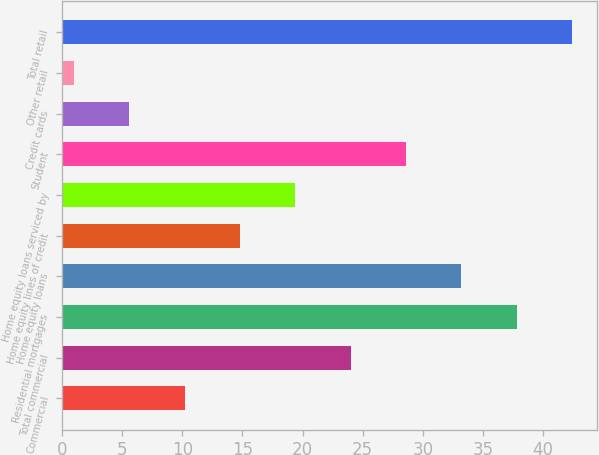Convert chart to OTSL. <chart><loc_0><loc_0><loc_500><loc_500><bar_chart><fcel>Commercial<fcel>Total commercial<fcel>Residential mortgages<fcel>Home equity loans<fcel>Home equity lines of credit<fcel>Home equity loans serviced by<fcel>Student<fcel>Credit cards<fcel>Other retail<fcel>Total retail<nl><fcel>10.2<fcel>24<fcel>37.8<fcel>33.2<fcel>14.8<fcel>19.4<fcel>28.6<fcel>5.6<fcel>1<fcel>42.4<nl></chart> 